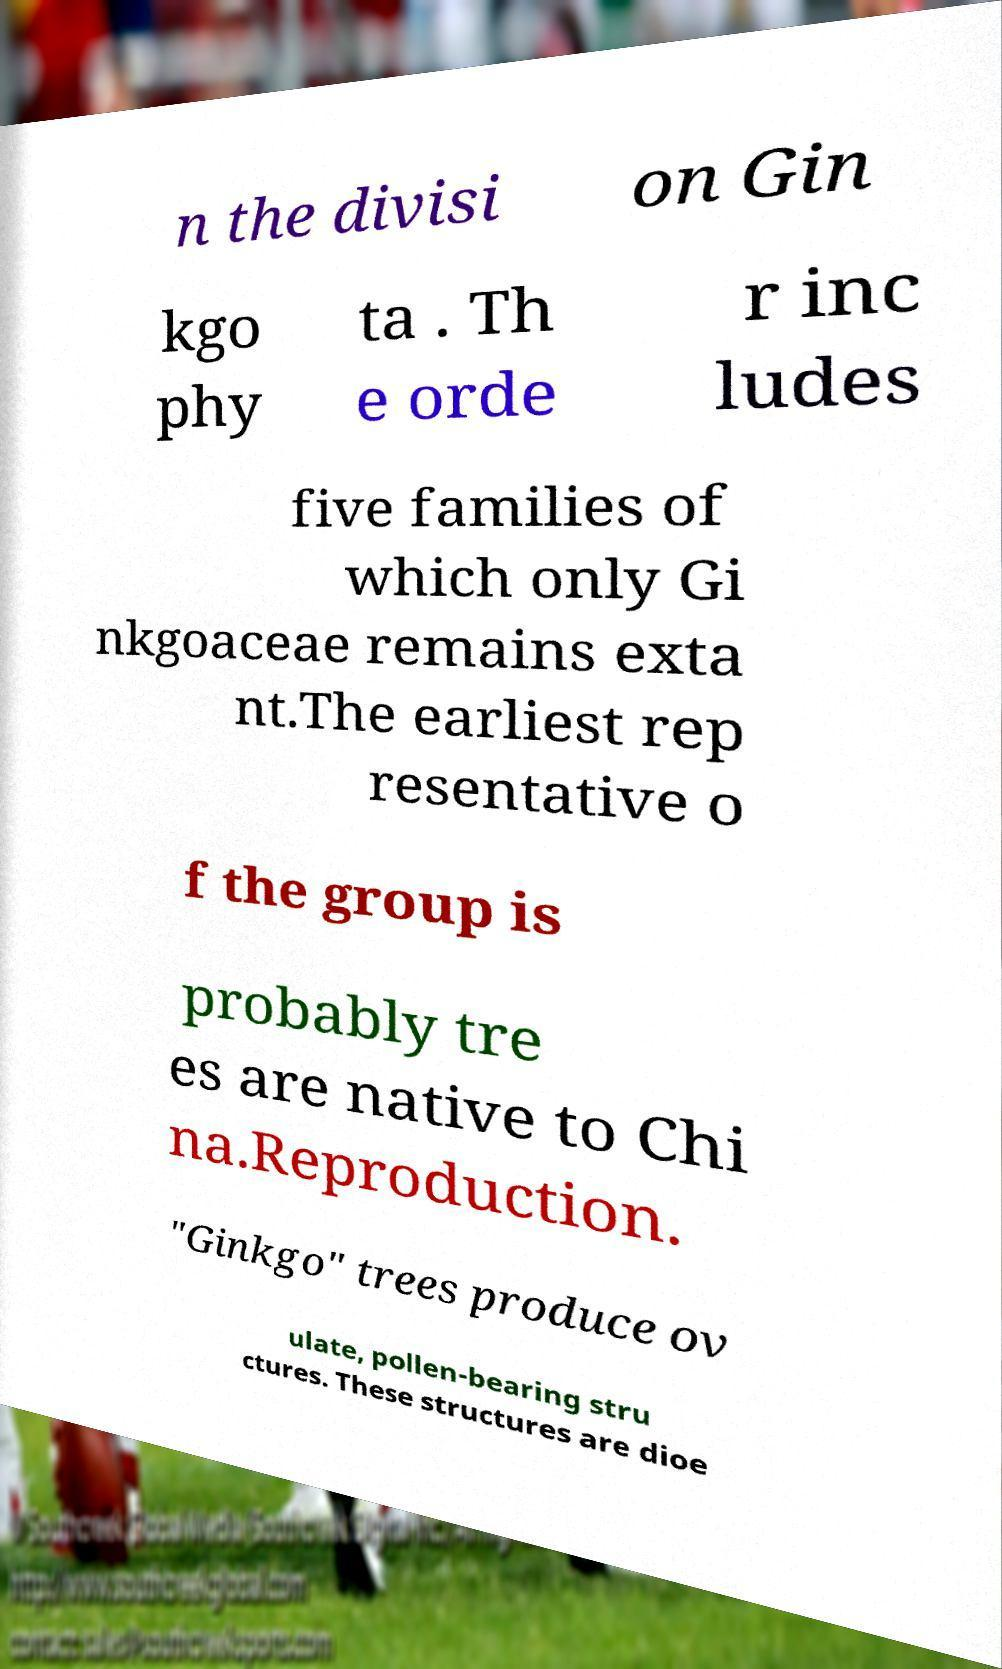Please identify and transcribe the text found in this image. n the divisi on Gin kgo phy ta . Th e orde r inc ludes five families of which only Gi nkgoaceae remains exta nt.The earliest rep resentative o f the group is probably tre es are native to Chi na.Reproduction. "Ginkgo" trees produce ov ulate, pollen-bearing stru ctures. These structures are dioe 